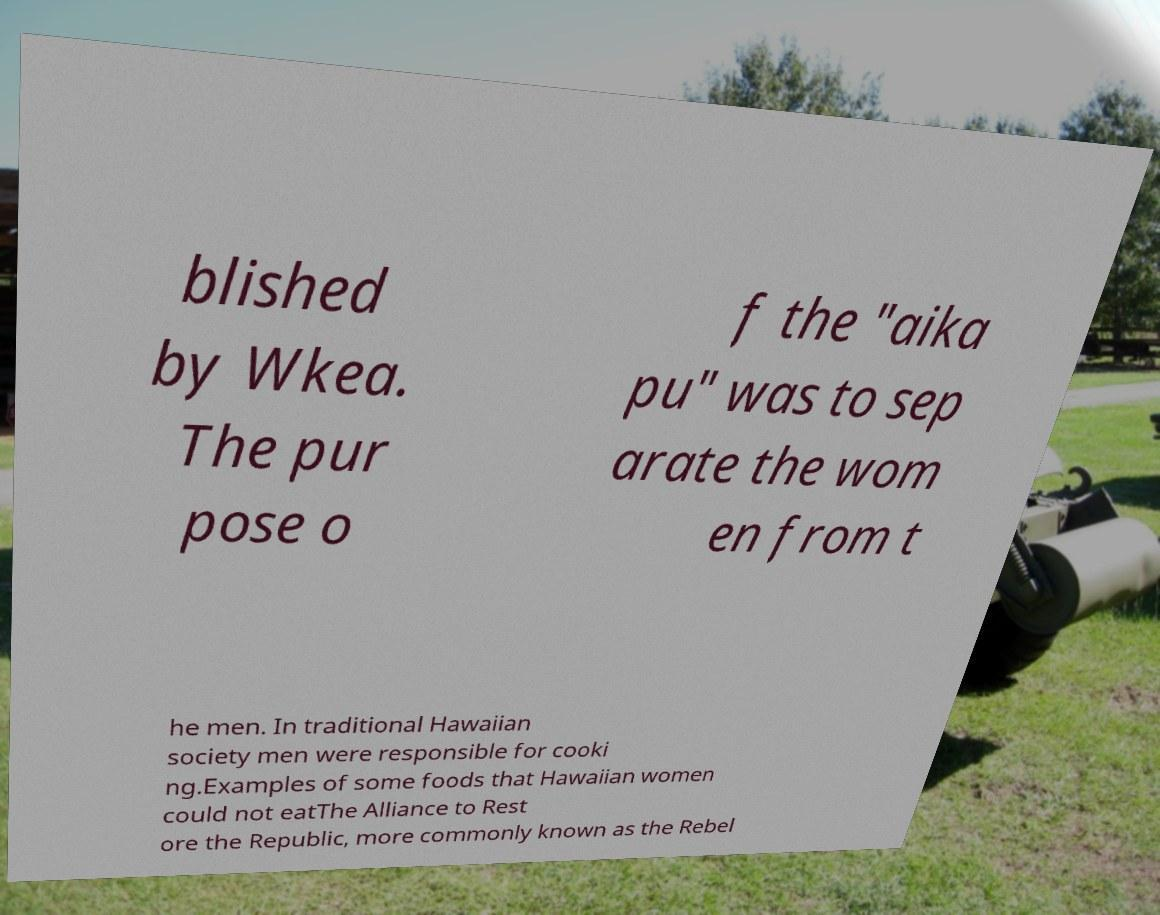Could you assist in decoding the text presented in this image and type it out clearly? blished by Wkea. The pur pose o f the "aika pu" was to sep arate the wom en from t he men. In traditional Hawaiian society men were responsible for cooki ng.Examples of some foods that Hawaiian women could not eatThe Alliance to Rest ore the Republic, more commonly known as the Rebel 